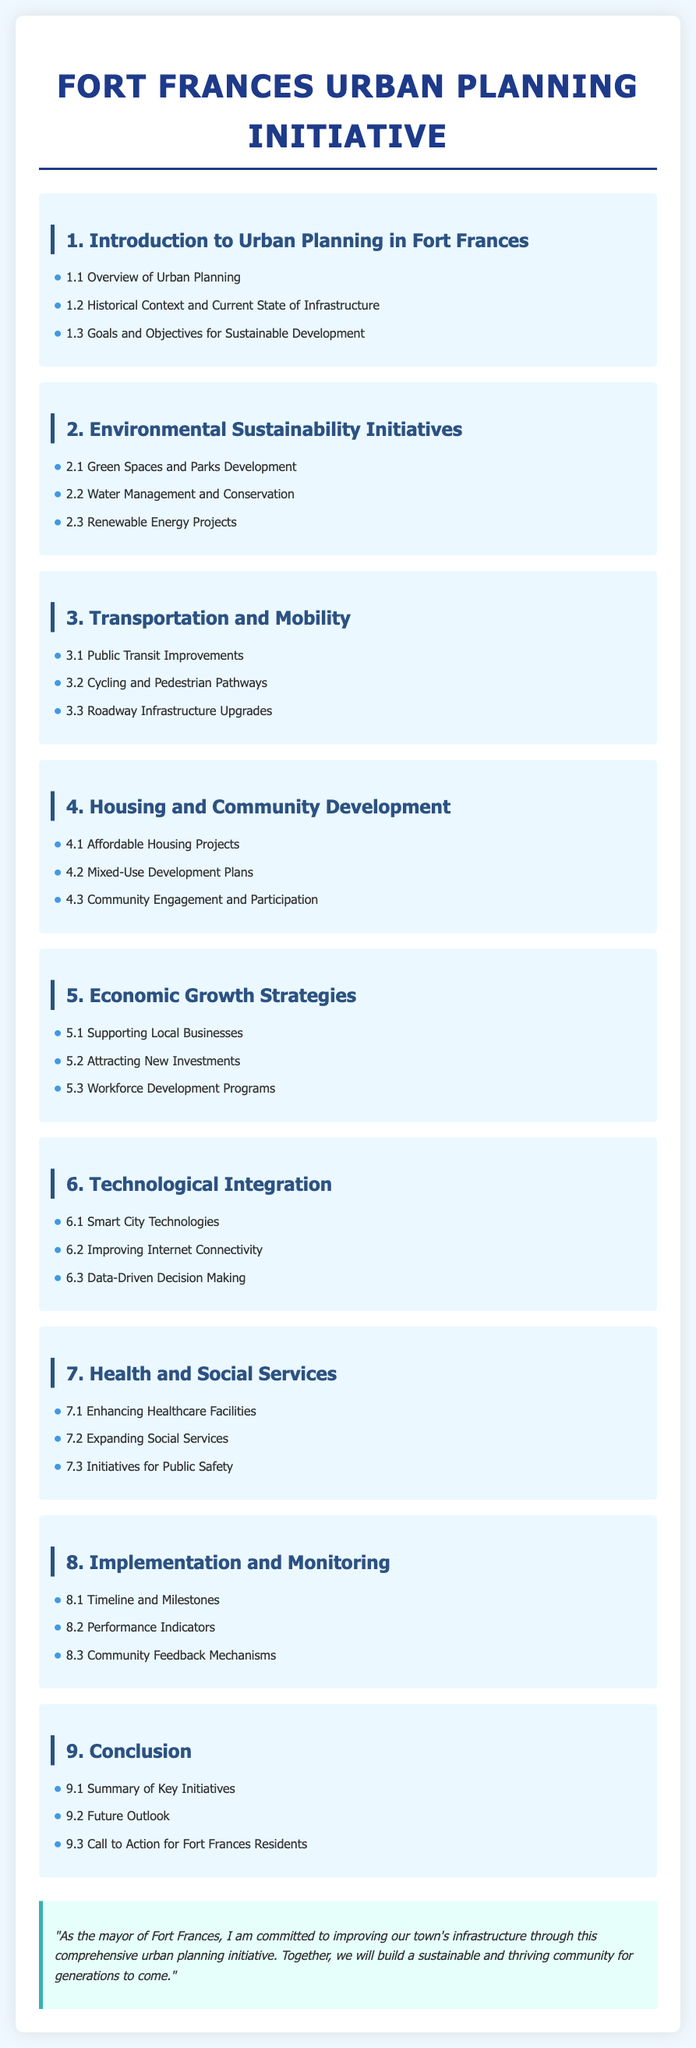What is the title of the document? The title is prominently displayed at the top of the document, which is "Fort Frances Urban Planning Initiative."
Answer: Fort Frances Urban Planning Initiative How many sections are there in the document? The main sections are numbered from 1 to 9, indicating there are nine sections in total.
Answer: 9 What is the focus of Section 2? Section 2 is dedicated to initiatives that promote environmental sustainability in Fort Frances.
Answer: Environmental Sustainability Initiatives What type of projects are discussed in Section 4.1? Section 4.1 specifically addresses initiatives aimed at providing essential housing options for residents.
Answer: Affordable Housing Projects In which section is public transit improvement mentioned? Public transit improvement is specifically covered under Section 3, pertaining to transportation and mobility aspects of urban planning.
Answer: Section 3 What is the purpose of the mayor's note at the end of the document? The mayor's note serves to express commitment to improving infrastructure and engaging the community towards that goal.
Answer: Commitment to improving infrastructure What do Section 8.2 focus on? Section 8.2 pertains to the metrics used to evaluate the performance of the urban planning initiatives outlined in the document.
Answer: Performance Indicators What is the primary goal of the comprehensive urban planning initiative? The overall aim is to create a sustainable and thriving community for Fort Frances.
Answer: Sustainable and thriving community Which section outlines the initiatives for public safety? Section 7 discusses various initiatives aimed at enhancing public safety and social services within Fort Frances.
Answer: Section 7 